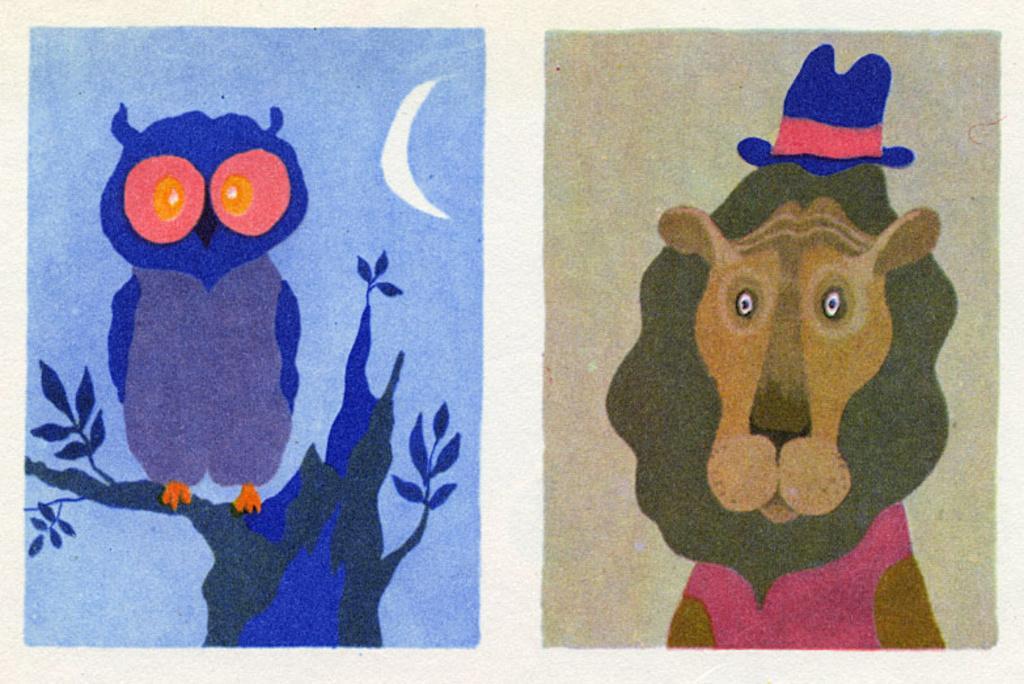Describe this image in one or two sentences. In this image we can see a paper and on the paper we can see an owl and a lion with a hat painting. 